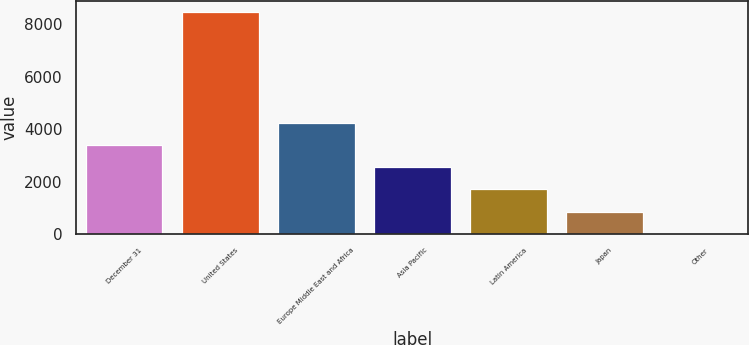<chart> <loc_0><loc_0><loc_500><loc_500><bar_chart><fcel>December 31<fcel>United States<fcel>Europe Middle East and Africa<fcel>Asia Pacific<fcel>Latin America<fcel>Japan<fcel>Other<nl><fcel>3391.6<fcel>8467<fcel>4237.5<fcel>2545.7<fcel>1699.8<fcel>853.9<fcel>8<nl></chart> 